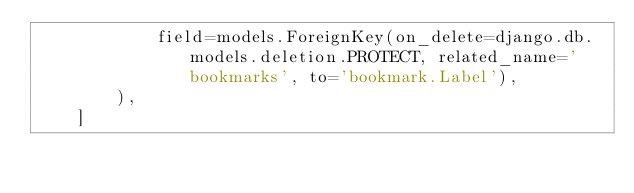Convert code to text. <code><loc_0><loc_0><loc_500><loc_500><_Python_>            field=models.ForeignKey(on_delete=django.db.models.deletion.PROTECT, related_name='bookmarks', to='bookmark.Label'),
        ),
    ]
</code> 